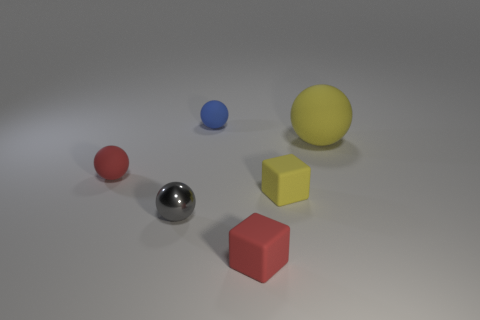What is the material of the other large thing that is the same shape as the blue rubber object?
Your answer should be very brief. Rubber. The tiny metallic sphere has what color?
Your answer should be very brief. Gray. How many objects are small metal spheres or large cylinders?
Your answer should be compact. 1. There is a matte thing that is to the left of the thing that is behind the large yellow rubber sphere; what is its shape?
Your answer should be very brief. Sphere. How many other things are the same material as the tiny red ball?
Offer a very short reply. 4. Are the tiny gray thing and the blue ball left of the big yellow sphere made of the same material?
Make the answer very short. No. What number of objects are either yellow matte objects in front of the large matte object or objects on the left side of the small blue rubber ball?
Make the answer very short. 3. What number of other objects are there of the same color as the large sphere?
Offer a terse response. 1. Are there more yellow matte objects that are in front of the yellow rubber sphere than blocks in front of the red rubber cube?
Provide a short and direct response. Yes. Is there any other thing that has the same size as the yellow matte ball?
Make the answer very short. No. 